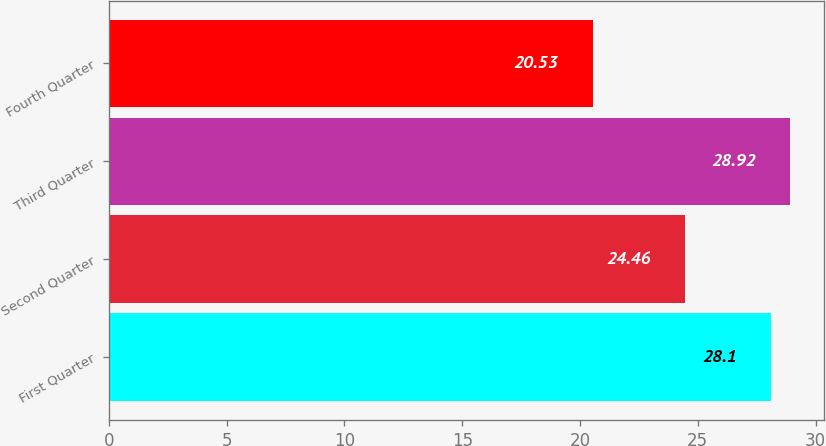Convert chart to OTSL. <chart><loc_0><loc_0><loc_500><loc_500><bar_chart><fcel>First Quarter<fcel>Second Quarter<fcel>Third Quarter<fcel>Fourth Quarter<nl><fcel>28.1<fcel>24.46<fcel>28.92<fcel>20.53<nl></chart> 